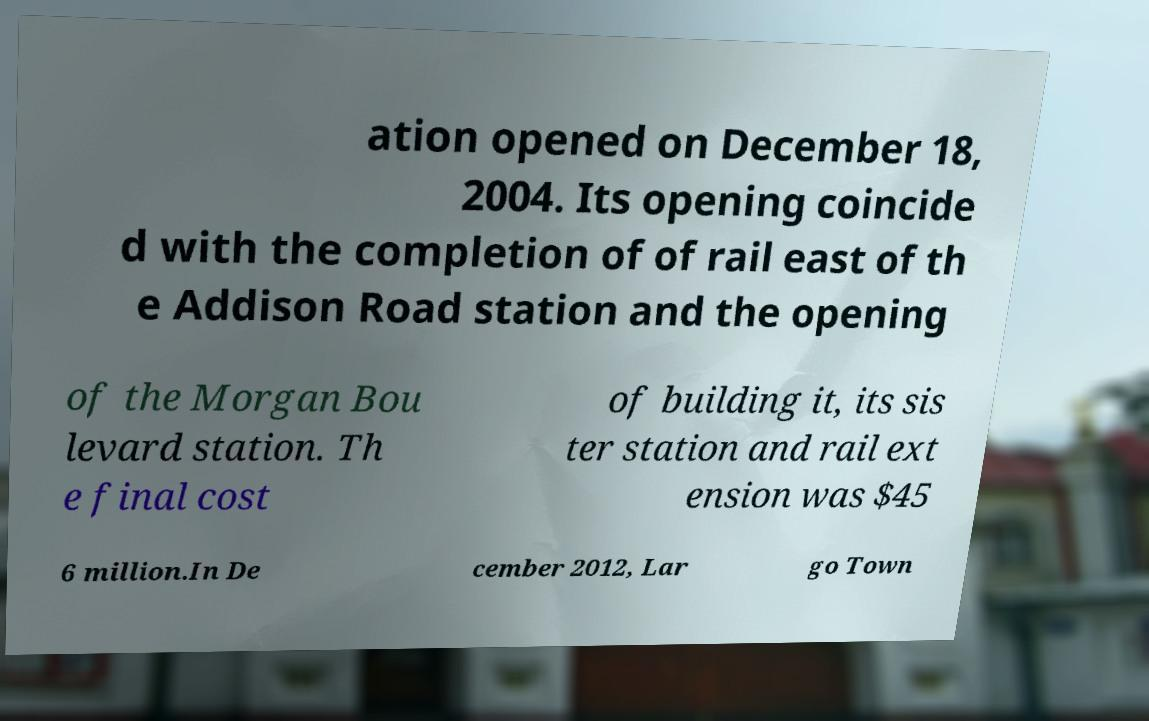Could you assist in decoding the text presented in this image and type it out clearly? ation opened on December 18, 2004. Its opening coincide d with the completion of of rail east of th e Addison Road station and the opening of the Morgan Bou levard station. Th e final cost of building it, its sis ter station and rail ext ension was $45 6 million.In De cember 2012, Lar go Town 